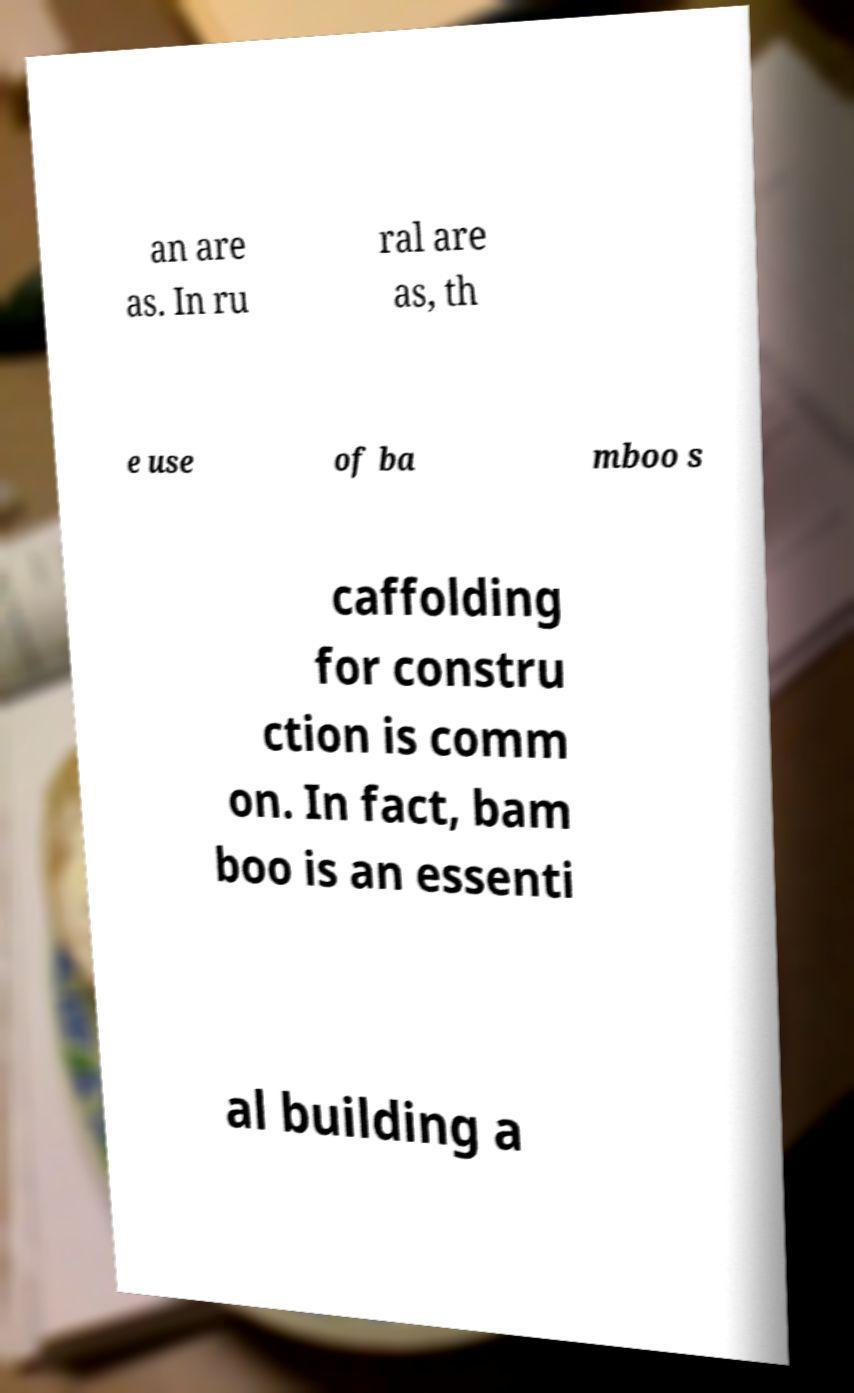I need the written content from this picture converted into text. Can you do that? an are as. In ru ral are as, th e use of ba mboo s caffolding for constru ction is comm on. In fact, bam boo is an essenti al building a 